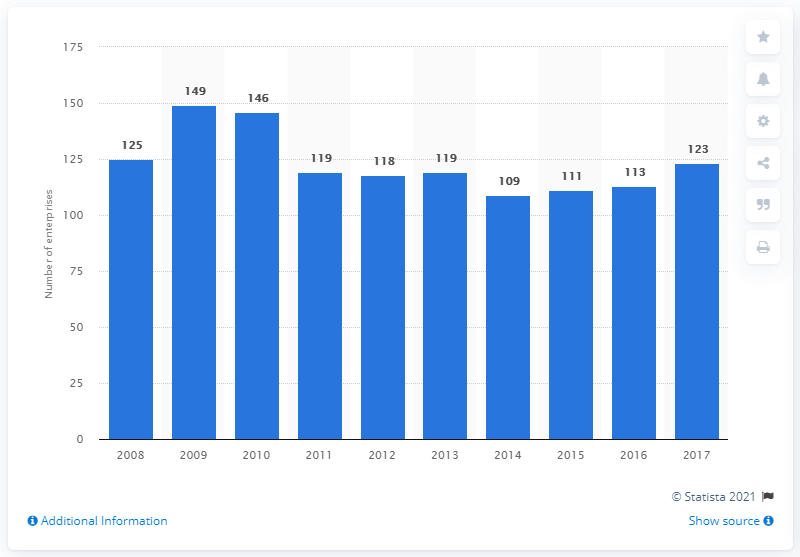Point out several critical features in this image. In 2017, there were 123 enterprises in Poland that manufactured electric domestic appliances. 